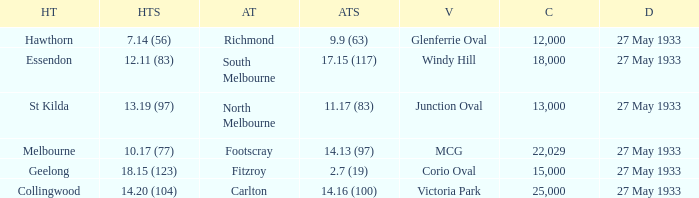In the match where the home team scored 14.20 (104), how many attendees were in the crowd? 25000.0. 